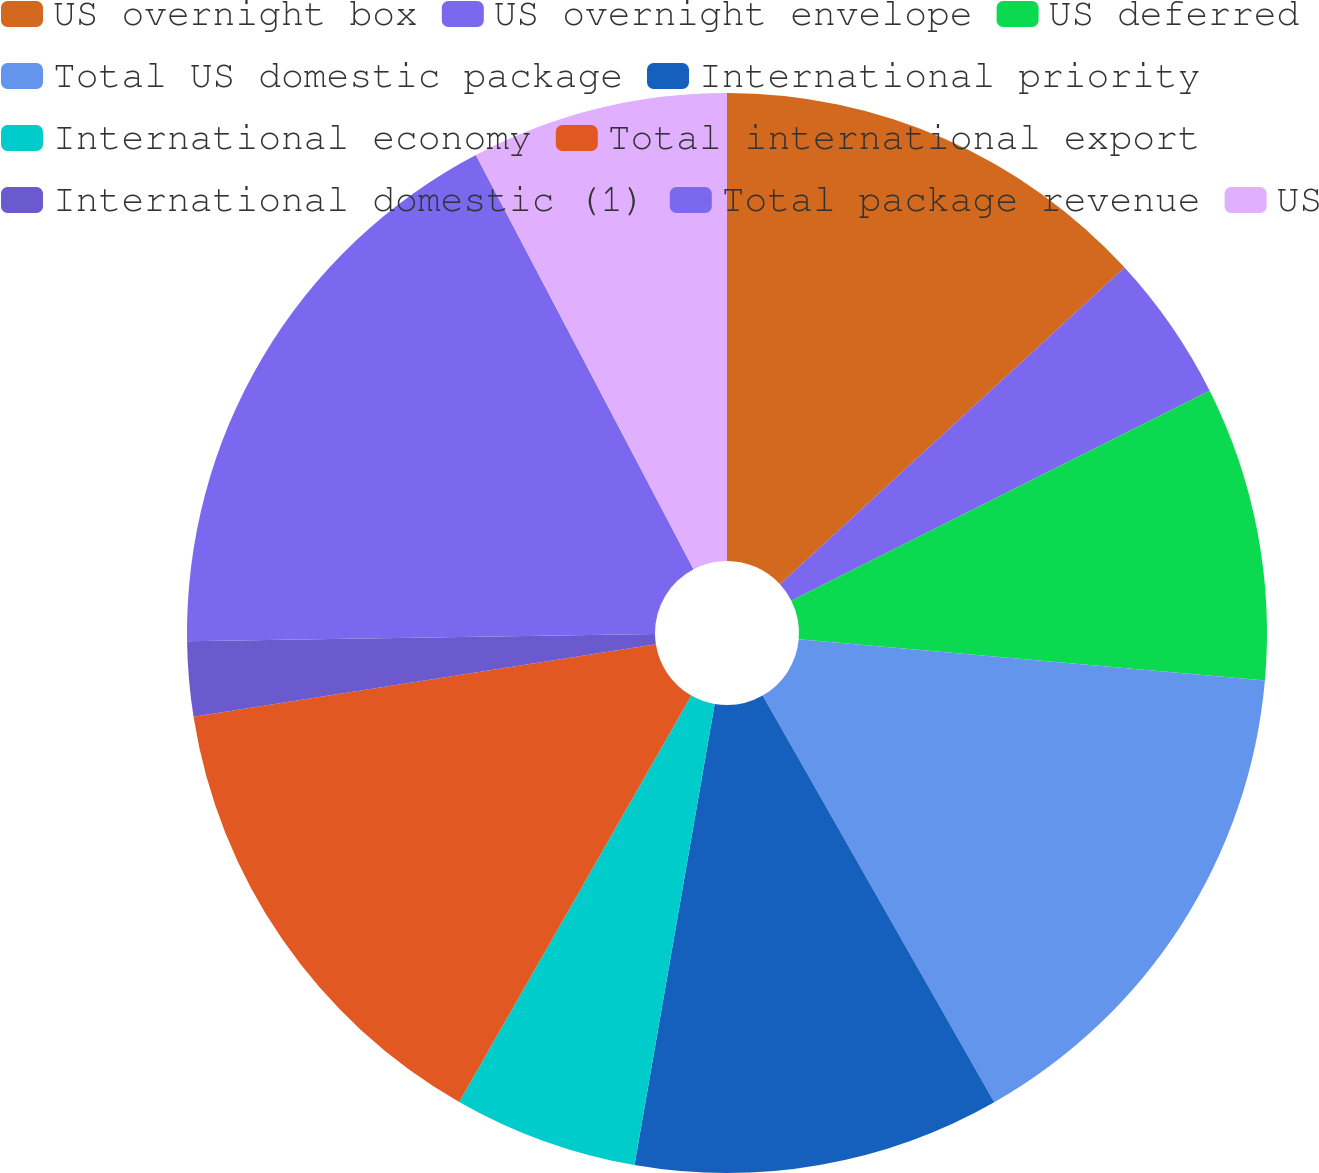Convert chart. <chart><loc_0><loc_0><loc_500><loc_500><pie_chart><fcel>US overnight box<fcel>US overnight envelope<fcel>US deferred<fcel>Total US domestic package<fcel>International priority<fcel>International economy<fcel>Total international export<fcel>International domestic (1)<fcel>Total package revenue<fcel>US<nl><fcel>13.17%<fcel>4.43%<fcel>8.8%<fcel>15.36%<fcel>10.98%<fcel>5.52%<fcel>14.26%<fcel>2.24%<fcel>17.54%<fcel>7.7%<nl></chart> 